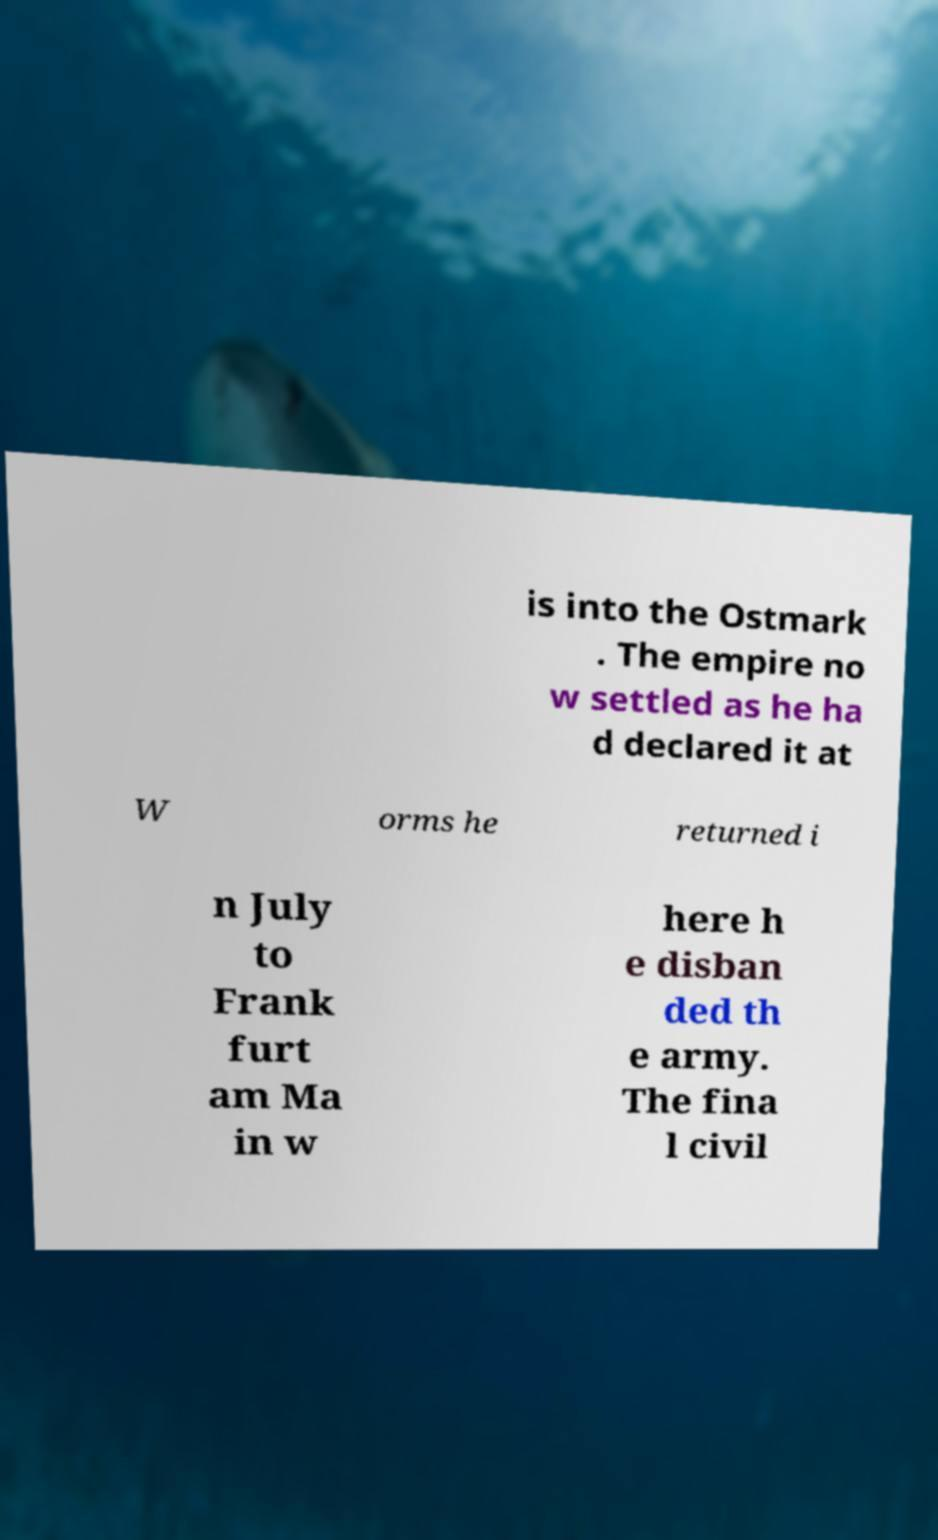Could you extract and type out the text from this image? is into the Ostmark . The empire no w settled as he ha d declared it at W orms he returned i n July to Frank furt am Ma in w here h e disban ded th e army. The fina l civil 